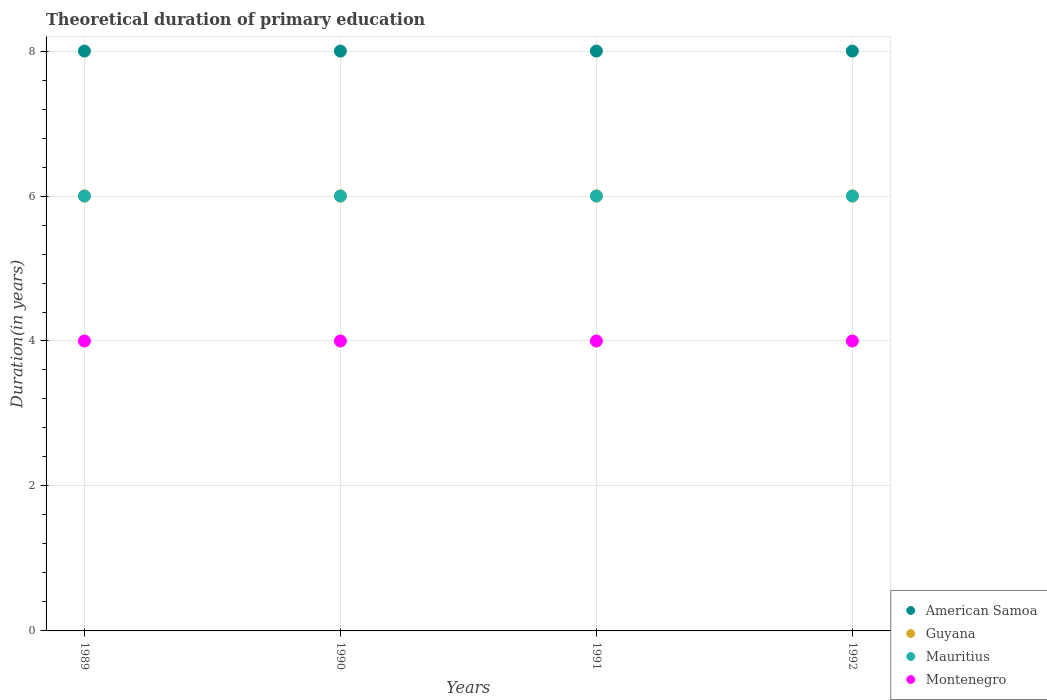What is the total theoretical duration of primary education in American Samoa in 1991?
Make the answer very short. 8. Across all years, what is the maximum total theoretical duration of primary education in American Samoa?
Provide a short and direct response. 8. In which year was the total theoretical duration of primary education in Mauritius maximum?
Offer a very short reply. 1989. In which year was the total theoretical duration of primary education in Mauritius minimum?
Your answer should be very brief. 1989. What is the total total theoretical duration of primary education in Guyana in the graph?
Your answer should be very brief. 24. What is the average total theoretical duration of primary education in Guyana per year?
Ensure brevity in your answer.  6. In the year 1989, what is the difference between the total theoretical duration of primary education in Guyana and total theoretical duration of primary education in Montenegro?
Keep it short and to the point. 2. In how many years, is the total theoretical duration of primary education in Montenegro greater than 4 years?
Offer a terse response. 0. Is the total theoretical duration of primary education in Mauritius in 1990 less than that in 1991?
Give a very brief answer. No. What is the difference between the highest and the second highest total theoretical duration of primary education in Montenegro?
Provide a succinct answer. 0. Is the sum of the total theoretical duration of primary education in Guyana in 1990 and 1992 greater than the maximum total theoretical duration of primary education in American Samoa across all years?
Make the answer very short. Yes. Is it the case that in every year, the sum of the total theoretical duration of primary education in Guyana and total theoretical duration of primary education in American Samoa  is greater than the total theoretical duration of primary education in Montenegro?
Give a very brief answer. Yes. Does the total theoretical duration of primary education in American Samoa monotonically increase over the years?
Your response must be concise. No. Is the total theoretical duration of primary education in Montenegro strictly less than the total theoretical duration of primary education in Guyana over the years?
Provide a succinct answer. Yes. What is the difference between two consecutive major ticks on the Y-axis?
Your response must be concise. 2. Does the graph contain any zero values?
Provide a short and direct response. No. Does the graph contain grids?
Make the answer very short. Yes. How many legend labels are there?
Keep it short and to the point. 4. What is the title of the graph?
Offer a terse response. Theoretical duration of primary education. What is the label or title of the Y-axis?
Offer a terse response. Duration(in years). What is the Duration(in years) in Guyana in 1989?
Provide a short and direct response. 6. What is the Duration(in years) in Mauritius in 1989?
Offer a very short reply. 6. What is the Duration(in years) of Montenegro in 1989?
Give a very brief answer. 4. What is the Duration(in years) of Guyana in 1990?
Provide a short and direct response. 6. What is the Duration(in years) in Mauritius in 1990?
Ensure brevity in your answer.  6. What is the Duration(in years) in Mauritius in 1992?
Provide a short and direct response. 6. What is the Duration(in years) of Montenegro in 1992?
Offer a terse response. 4. Across all years, what is the maximum Duration(in years) in Guyana?
Your answer should be very brief. 6. Across all years, what is the maximum Duration(in years) in Montenegro?
Provide a short and direct response. 4. What is the total Duration(in years) in American Samoa in the graph?
Offer a very short reply. 32. What is the difference between the Duration(in years) in American Samoa in 1989 and that in 1990?
Your answer should be compact. 0. What is the difference between the Duration(in years) in Mauritius in 1989 and that in 1990?
Make the answer very short. 0. What is the difference between the Duration(in years) of American Samoa in 1989 and that in 1991?
Give a very brief answer. 0. What is the difference between the Duration(in years) of Mauritius in 1989 and that in 1991?
Make the answer very short. 0. What is the difference between the Duration(in years) of Mauritius in 1989 and that in 1992?
Ensure brevity in your answer.  0. What is the difference between the Duration(in years) of Mauritius in 1990 and that in 1991?
Your answer should be very brief. 0. What is the difference between the Duration(in years) of Mauritius in 1990 and that in 1992?
Your response must be concise. 0. What is the difference between the Duration(in years) of Guyana in 1991 and that in 1992?
Offer a terse response. 0. What is the difference between the Duration(in years) in American Samoa in 1989 and the Duration(in years) in Guyana in 1990?
Your response must be concise. 2. What is the difference between the Duration(in years) in American Samoa in 1989 and the Duration(in years) in Montenegro in 1990?
Provide a succinct answer. 4. What is the difference between the Duration(in years) of Guyana in 1989 and the Duration(in years) of Mauritius in 1990?
Your answer should be compact. 0. What is the difference between the Duration(in years) in American Samoa in 1989 and the Duration(in years) in Guyana in 1991?
Offer a very short reply. 2. What is the difference between the Duration(in years) in Guyana in 1989 and the Duration(in years) in Mauritius in 1991?
Offer a very short reply. 0. What is the difference between the Duration(in years) in Mauritius in 1989 and the Duration(in years) in Montenegro in 1991?
Provide a short and direct response. 2. What is the difference between the Duration(in years) in American Samoa in 1989 and the Duration(in years) in Montenegro in 1992?
Your response must be concise. 4. What is the difference between the Duration(in years) of Guyana in 1989 and the Duration(in years) of Mauritius in 1992?
Ensure brevity in your answer.  0. What is the difference between the Duration(in years) in Guyana in 1989 and the Duration(in years) in Montenegro in 1992?
Your answer should be very brief. 2. What is the difference between the Duration(in years) in Mauritius in 1989 and the Duration(in years) in Montenegro in 1992?
Ensure brevity in your answer.  2. What is the difference between the Duration(in years) in American Samoa in 1990 and the Duration(in years) in Montenegro in 1991?
Provide a short and direct response. 4. What is the difference between the Duration(in years) of Guyana in 1990 and the Duration(in years) of Mauritius in 1991?
Give a very brief answer. 0. What is the difference between the Duration(in years) in Mauritius in 1990 and the Duration(in years) in Montenegro in 1991?
Offer a very short reply. 2. What is the difference between the Duration(in years) of American Samoa in 1990 and the Duration(in years) of Mauritius in 1992?
Keep it short and to the point. 2. What is the difference between the Duration(in years) in American Samoa in 1990 and the Duration(in years) in Montenegro in 1992?
Provide a succinct answer. 4. What is the difference between the Duration(in years) in American Samoa in 1991 and the Duration(in years) in Montenegro in 1992?
Your response must be concise. 4. What is the difference between the Duration(in years) of Guyana in 1991 and the Duration(in years) of Mauritius in 1992?
Ensure brevity in your answer.  0. What is the difference between the Duration(in years) in Guyana in 1991 and the Duration(in years) in Montenegro in 1992?
Provide a succinct answer. 2. What is the average Duration(in years) in Montenegro per year?
Offer a terse response. 4. In the year 1989, what is the difference between the Duration(in years) of American Samoa and Duration(in years) of Montenegro?
Offer a very short reply. 4. In the year 1989, what is the difference between the Duration(in years) of Guyana and Duration(in years) of Mauritius?
Provide a succinct answer. 0. In the year 1989, what is the difference between the Duration(in years) of Mauritius and Duration(in years) of Montenegro?
Your response must be concise. 2. In the year 1990, what is the difference between the Duration(in years) of American Samoa and Duration(in years) of Guyana?
Make the answer very short. 2. In the year 1990, what is the difference between the Duration(in years) in American Samoa and Duration(in years) in Mauritius?
Provide a succinct answer. 2. In the year 1990, what is the difference between the Duration(in years) of Guyana and Duration(in years) of Mauritius?
Offer a very short reply. 0. In the year 1990, what is the difference between the Duration(in years) of Mauritius and Duration(in years) of Montenegro?
Ensure brevity in your answer.  2. In the year 1991, what is the difference between the Duration(in years) of American Samoa and Duration(in years) of Montenegro?
Keep it short and to the point. 4. In the year 1991, what is the difference between the Duration(in years) in Guyana and Duration(in years) in Montenegro?
Offer a terse response. 2. In the year 1991, what is the difference between the Duration(in years) in Mauritius and Duration(in years) in Montenegro?
Offer a terse response. 2. In the year 1992, what is the difference between the Duration(in years) in American Samoa and Duration(in years) in Mauritius?
Give a very brief answer. 2. In the year 1992, what is the difference between the Duration(in years) in American Samoa and Duration(in years) in Montenegro?
Keep it short and to the point. 4. In the year 1992, what is the difference between the Duration(in years) of Guyana and Duration(in years) of Mauritius?
Offer a terse response. 0. In the year 1992, what is the difference between the Duration(in years) in Mauritius and Duration(in years) in Montenegro?
Your answer should be compact. 2. What is the ratio of the Duration(in years) in Mauritius in 1989 to that in 1990?
Give a very brief answer. 1. What is the ratio of the Duration(in years) in American Samoa in 1989 to that in 1991?
Make the answer very short. 1. What is the ratio of the Duration(in years) of Guyana in 1989 to that in 1991?
Give a very brief answer. 1. What is the ratio of the Duration(in years) in Mauritius in 1989 to that in 1991?
Offer a very short reply. 1. What is the ratio of the Duration(in years) of Montenegro in 1989 to that in 1991?
Your answer should be very brief. 1. What is the ratio of the Duration(in years) in Guyana in 1989 to that in 1992?
Your answer should be very brief. 1. What is the ratio of the Duration(in years) of Mauritius in 1989 to that in 1992?
Offer a terse response. 1. What is the ratio of the Duration(in years) in Montenegro in 1989 to that in 1992?
Provide a short and direct response. 1. What is the ratio of the Duration(in years) in American Samoa in 1990 to that in 1991?
Provide a short and direct response. 1. What is the ratio of the Duration(in years) of Guyana in 1990 to that in 1991?
Your answer should be very brief. 1. What is the ratio of the Duration(in years) in Mauritius in 1990 to that in 1991?
Keep it short and to the point. 1. What is the ratio of the Duration(in years) of Montenegro in 1990 to that in 1991?
Ensure brevity in your answer.  1. What is the ratio of the Duration(in years) of Guyana in 1990 to that in 1992?
Provide a succinct answer. 1. What is the ratio of the Duration(in years) in Mauritius in 1990 to that in 1992?
Provide a succinct answer. 1. What is the ratio of the Duration(in years) of Montenegro in 1990 to that in 1992?
Give a very brief answer. 1. What is the ratio of the Duration(in years) of American Samoa in 1991 to that in 1992?
Ensure brevity in your answer.  1. What is the ratio of the Duration(in years) in Guyana in 1991 to that in 1992?
Make the answer very short. 1. What is the difference between the highest and the second highest Duration(in years) in American Samoa?
Your response must be concise. 0. What is the difference between the highest and the second highest Duration(in years) in Guyana?
Keep it short and to the point. 0. What is the difference between the highest and the lowest Duration(in years) of American Samoa?
Provide a short and direct response. 0. What is the difference between the highest and the lowest Duration(in years) in Guyana?
Offer a terse response. 0. What is the difference between the highest and the lowest Duration(in years) of Mauritius?
Make the answer very short. 0. 